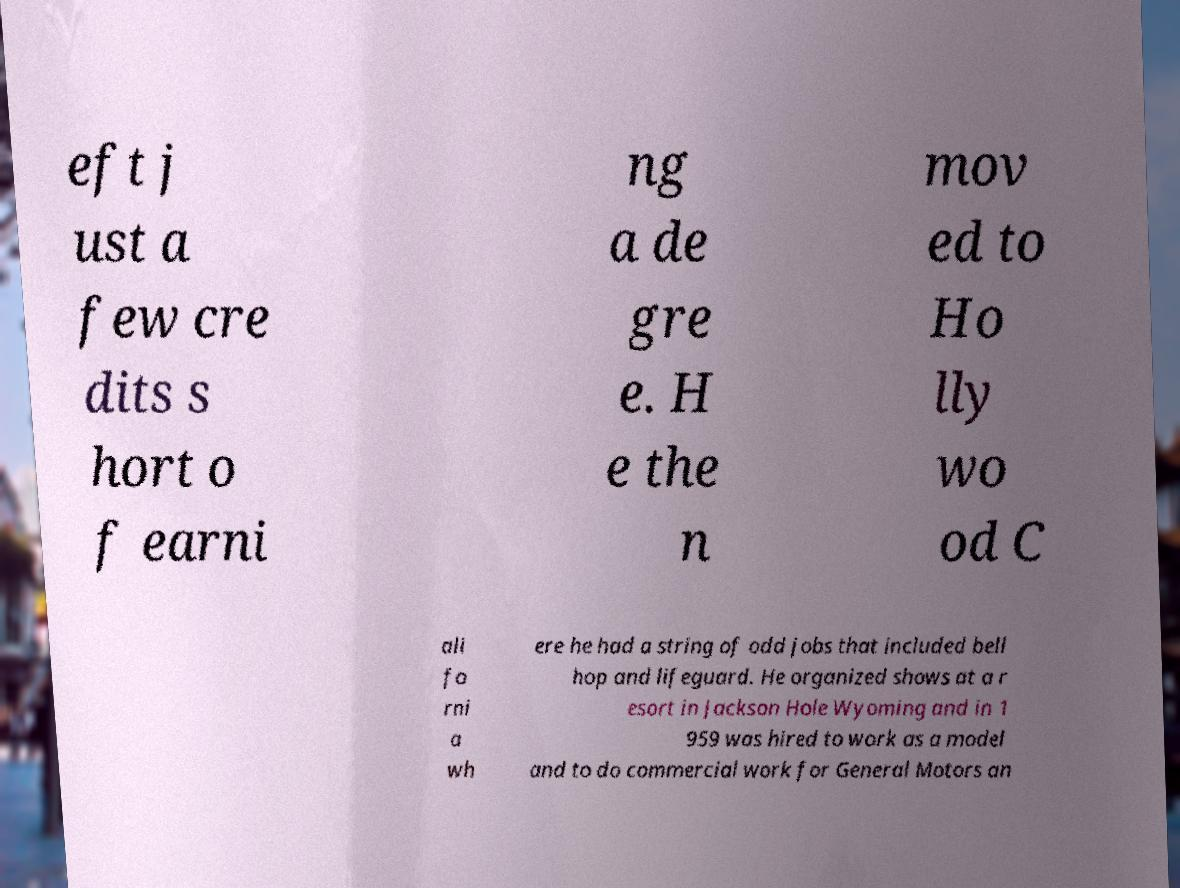For documentation purposes, I need the text within this image transcribed. Could you provide that? eft j ust a few cre dits s hort o f earni ng a de gre e. H e the n mov ed to Ho lly wo od C ali fo rni a wh ere he had a string of odd jobs that included bell hop and lifeguard. He organized shows at a r esort in Jackson Hole Wyoming and in 1 959 was hired to work as a model and to do commercial work for General Motors an 